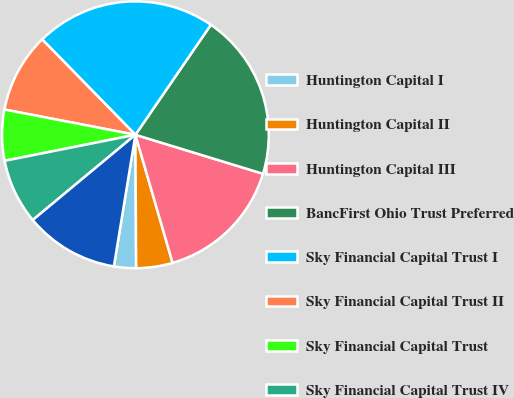<chart> <loc_0><loc_0><loc_500><loc_500><pie_chart><fcel>Huntington Capital I<fcel>Huntington Capital II<fcel>Huntington Capital III<fcel>BancFirst Ohio Trust Preferred<fcel>Sky Financial Capital Trust I<fcel>Sky Financial Capital Trust II<fcel>Sky Financial Capital Trust<fcel>Sky Financial Capital Trust IV<fcel>Prospect Trust I<nl><fcel>2.67%<fcel>4.41%<fcel>15.78%<fcel>20.15%<fcel>21.89%<fcel>9.65%<fcel>6.16%<fcel>7.9%<fcel>11.39%<nl></chart> 